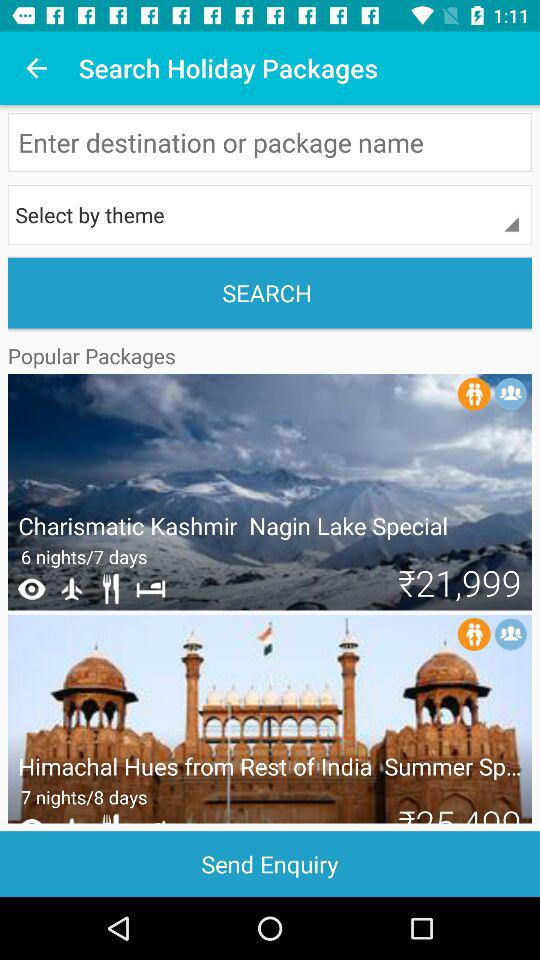What are the popular packages? The popular packages are Charismatic Kashmir Nagin Lake Special and "Himachal Hues from Rest of India Summer Sp...". 